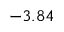Convert formula to latex. <formula><loc_0><loc_0><loc_500><loc_500>- 3 . 8 4</formula> 